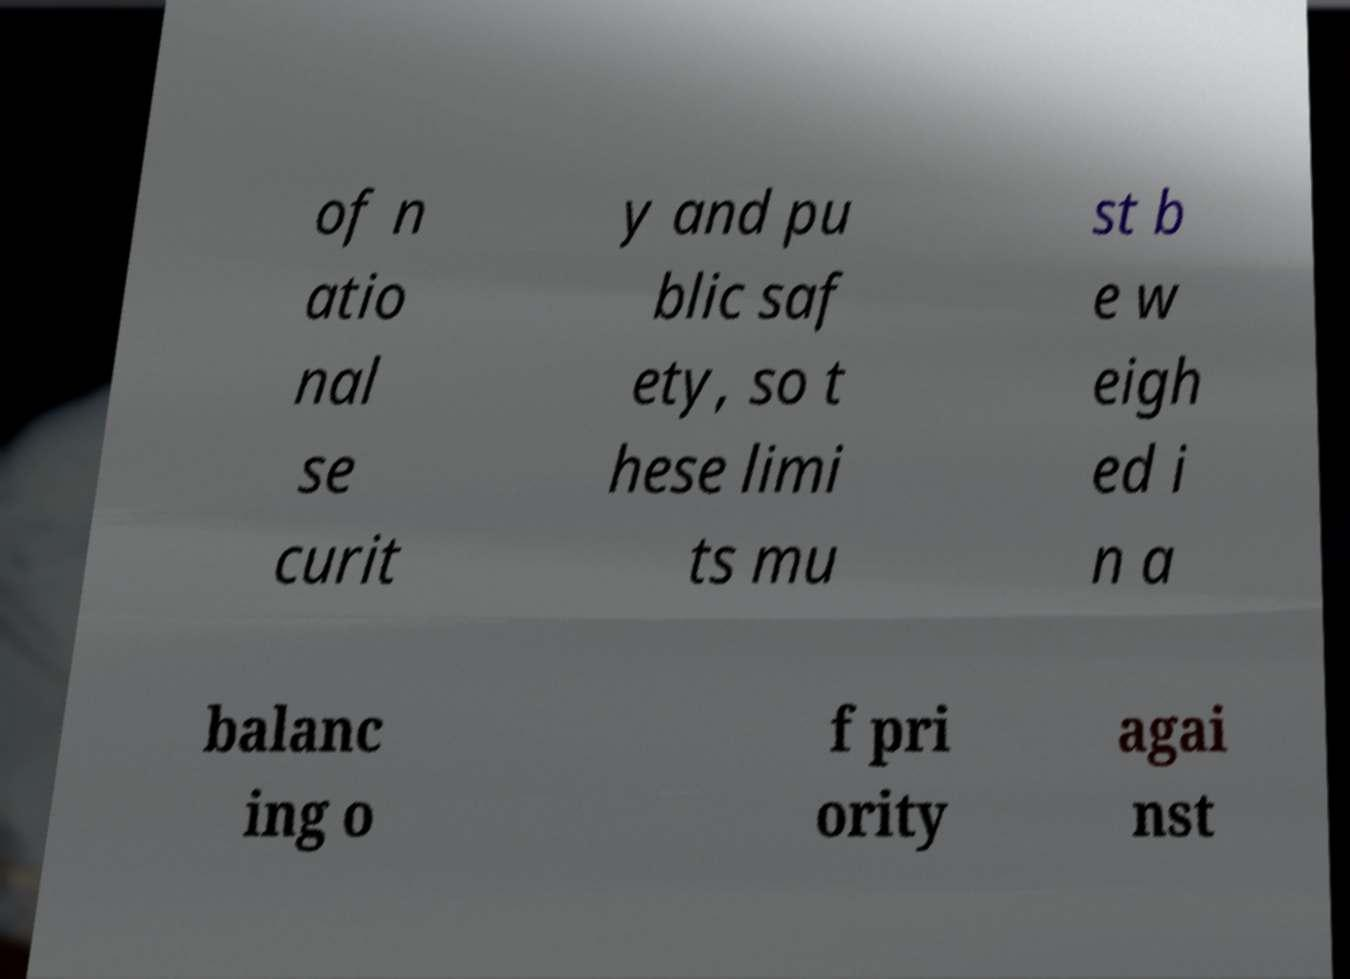Please identify and transcribe the text found in this image. of n atio nal se curit y and pu blic saf ety, so t hese limi ts mu st b e w eigh ed i n a balanc ing o f pri ority agai nst 